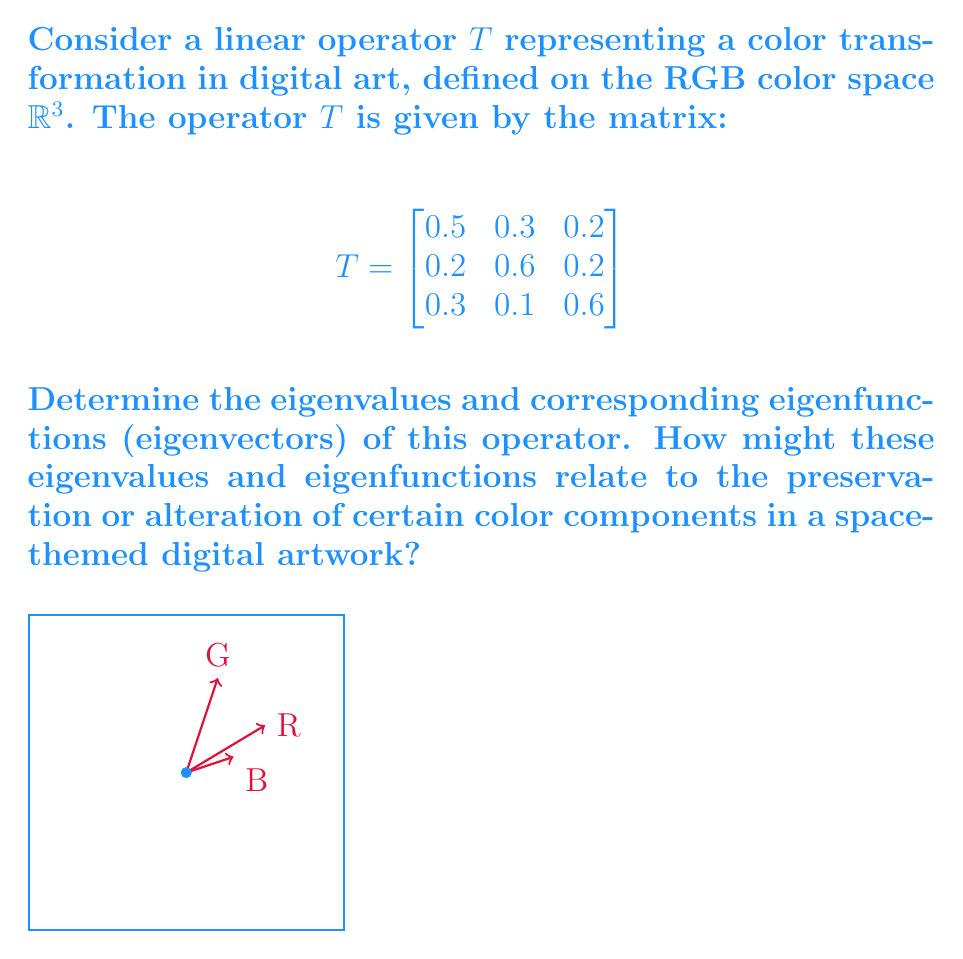Solve this math problem. To find the eigenvalues and eigenfunctions of the linear operator $T$, we follow these steps:

1) First, we need to find the characteristic polynomial of $T$:
   $$det(T - \lambda I) = \begin{vmatrix}
   0.5-\lambda & 0.3 & 0.2 \\
   0.2 & 0.6-\lambda & 0.2 \\
   0.3 & 0.1 & 0.6-\lambda
   \end{vmatrix}$$

2) Expanding this determinant:
   $$(0.5-\lambda)((0.6-\lambda)(0.6-\lambda)-0.02) - 0.3(0.2(0.6-\lambda)-0.06) + 0.2(0.06-0.3(0.6-\lambda))$$
   $$= -\lambda^3 + 1.7\lambda^2 - 0.83\lambda + 0.13$$

3) The roots of this polynomial are the eigenvalues. Using a numerical method or a computer algebra system, we find:
   $$\lambda_1 \approx 1, \lambda_2 \approx 0.4, \lambda_3 \approx 0.3$$

4) For each eigenvalue $\lambda_i$, we solve $(T - \lambda_i I)v = 0$ to find the corresponding eigenvector:

   For $\lambda_1 = 1$:
   $$\begin{bmatrix}
   -0.5 & 0.3 & 0.2 \\
   0.2 & -0.4 & 0.2 \\
   0.3 & 0.1 & -0.4
   \end{bmatrix} \begin{bmatrix} v_1 \\ v_2 \\ v_3 \end{bmatrix} = \begin{bmatrix} 0 \\ 0 \\ 0 \end{bmatrix}$$
   Solving this gives us $v_1 \approx (0.7071, 0.5774, 0.4082)$

   Similarly, for $\lambda_2 \approx 0.4$ and $\lambda_3 \approx 0.3$, we get:
   $v_2 \approx (-0.6124, 0.7715, -0.1715)$
   $v_3 \approx (0.3536, -0.2673, -0.8962)$

5) These eigenvectors represent the color components that are scaled by the corresponding eigenvalues under this transformation. 

   The eigenvalue close to 1 (λ₁) suggests that the corresponding color component (a mix of R, G, and B with more emphasis on R) is mostly preserved.
   
   The smaller eigenvalues (λ₂ and λ₃) indicate color components that are diminished by the transformation.

In a space-themed artwork, this transformation might enhance certain color combinations while muting others, potentially creating a desired atmospheric effect or emphasizing particular features of celestial objects.
Answer: Eigenvalues: $\lambda_1 \approx 1, \lambda_2 \approx 0.4, \lambda_3 \approx 0.3$
Eigenvectors: $v_1 \approx (0.7071, 0.5774, 0.4082)$, $v_2 \approx (-0.6124, 0.7715, -0.1715)$, $v_3 \approx (0.3536, -0.2673, -0.8962)$ 